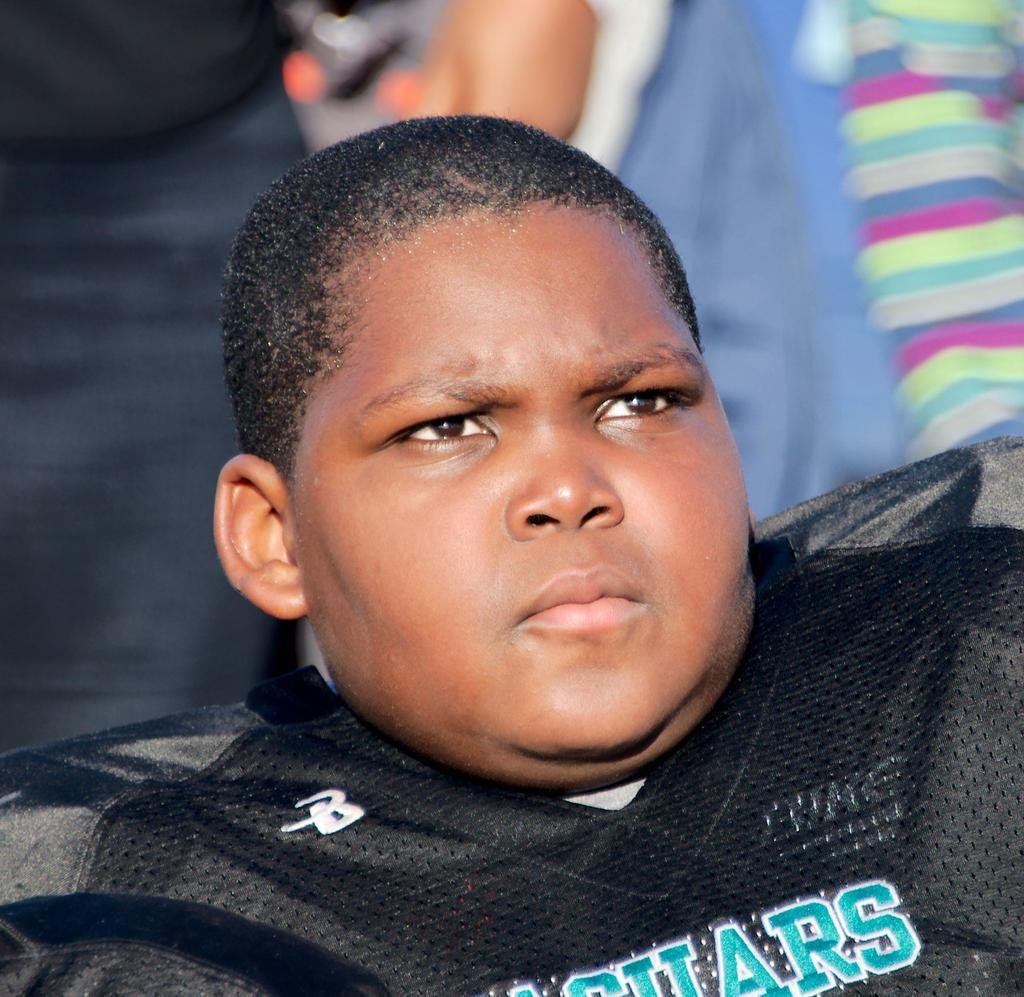Who is the main subject in the picture? There is a boy in the picture. What is the boy wearing? The boy is wearing a black dress. What advice does the boy's grandmother give him in the picture? There is no indication of a grandmother or any advice being given in the image. What type of sponge is the boy holding in the picture? There is no sponge present in the image. 